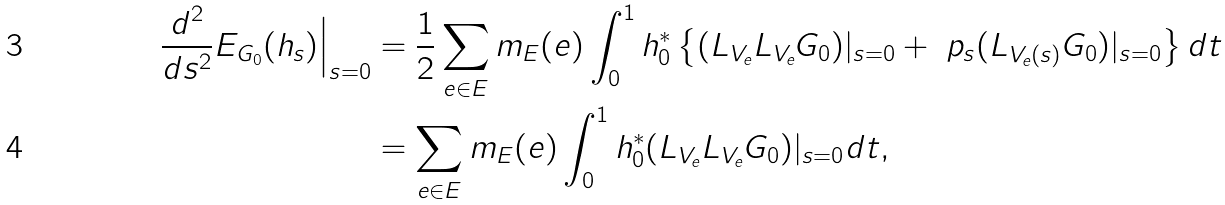Convert formula to latex. <formula><loc_0><loc_0><loc_500><loc_500>\frac { d ^ { 2 } } { d s ^ { 2 } } E _ { G _ { 0 } } ( h _ { s } ) \Big { | } _ { s = 0 } & = \frac { 1 } { 2 } \sum _ { e \in E } m _ { E } ( e ) \int _ { 0 } ^ { 1 } h _ { 0 } ^ { * } \left \{ ( L _ { V _ { e } } L _ { V _ { e } } G _ { 0 } ) | _ { s = 0 } + \ p _ { s } ( L _ { V _ { e } ( s ) } G _ { 0 } ) | _ { s = 0 } \right \} d t \\ & = \sum _ { e \in E } m _ { E } ( e ) \int _ { 0 } ^ { 1 } h _ { 0 } ^ { * } ( L _ { V _ { e } } L _ { V _ { e } } G _ { 0 } ) | _ { s = 0 } d t ,</formula> 